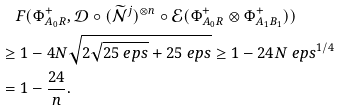<formula> <loc_0><loc_0><loc_500><loc_500>& \quad F ( \Phi ^ { + } _ { A _ { 0 } R } , \mathcal { D } \circ ( \widetilde { \mathcal { N } } ^ { j } ) ^ { \otimes n } \circ \mathcal { E } ( \Phi ^ { + } _ { A _ { 0 } R } \otimes \Phi ^ { + } _ { A _ { 1 } B _ { 1 } } ) ) \\ & \geq 1 - 4 N \sqrt { 2 \sqrt { 2 5 \ e p s } + 2 5 \ e p s } \geq 1 - 2 4 N \ e p s ^ { 1 / 4 } \\ & = 1 - \frac { 2 4 } n .</formula> 